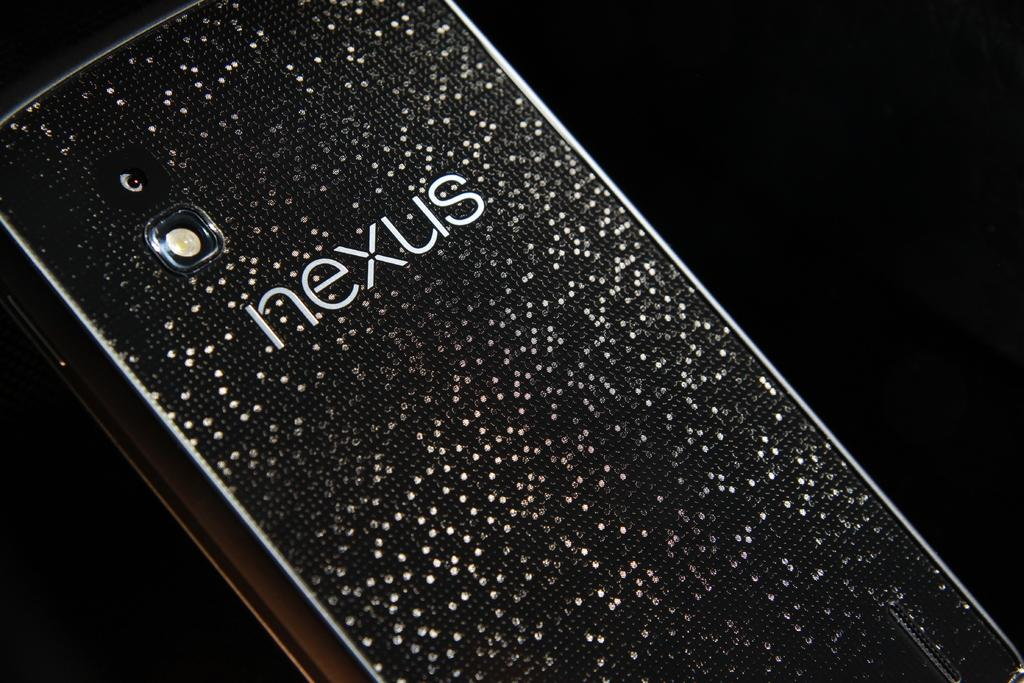<image>
Present a compact description of the photo's key features. the word nexus that is on a phone 